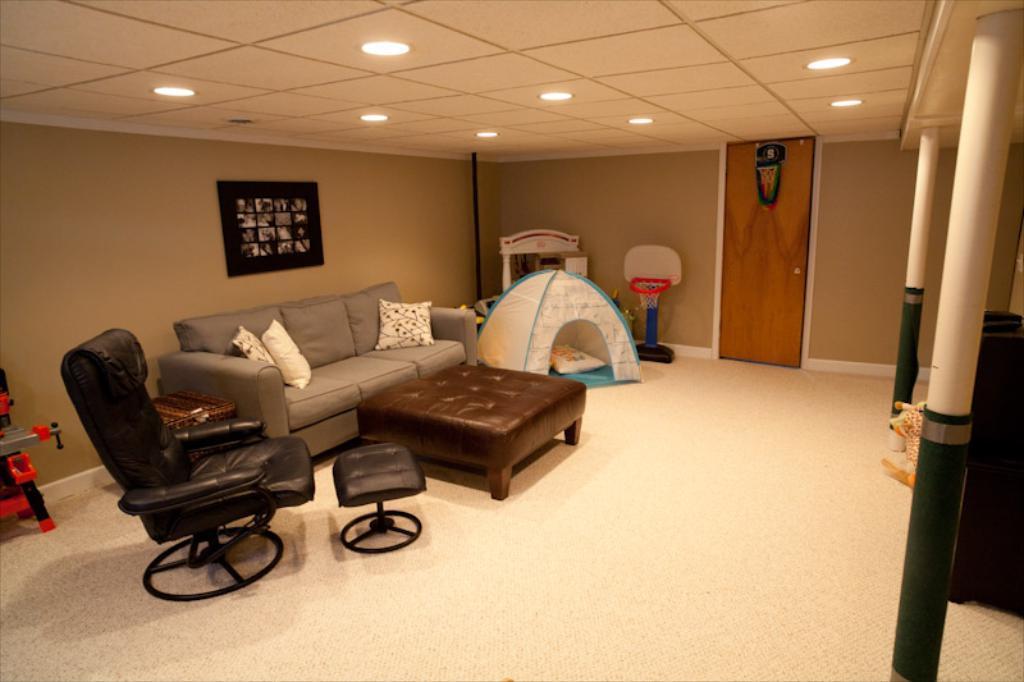Can you describe this image briefly? In this image we have a sofa, a chair and a door and ceiling. Behind the sofa we have a wall with a wall photo on it. 